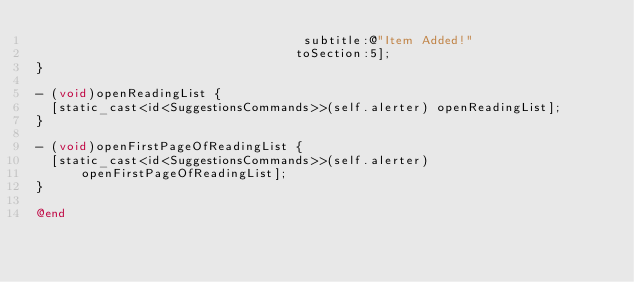<code> <loc_0><loc_0><loc_500><loc_500><_ObjectiveC_>                                    subtitle:@"Item Added!"
                                   toSection:5];
}

- (void)openReadingList {
  [static_cast<id<SuggestionsCommands>>(self.alerter) openReadingList];
}

- (void)openFirstPageOfReadingList {
  [static_cast<id<SuggestionsCommands>>(self.alerter)
      openFirstPageOfReadingList];
}

@end
</code> 